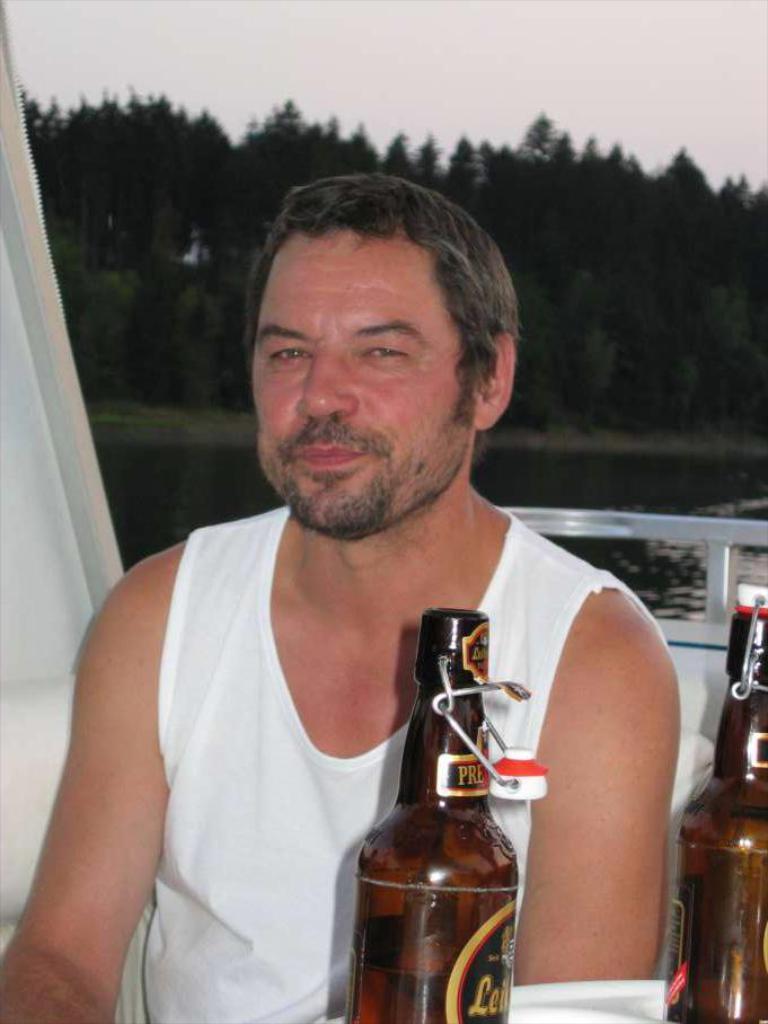How would you summarize this image in a sentence or two? A man travelling in the boat who is posing for the picture who wore a white color half sleeves tee shirt and has two bottles in front of him and also some trees behind him on the shore. 